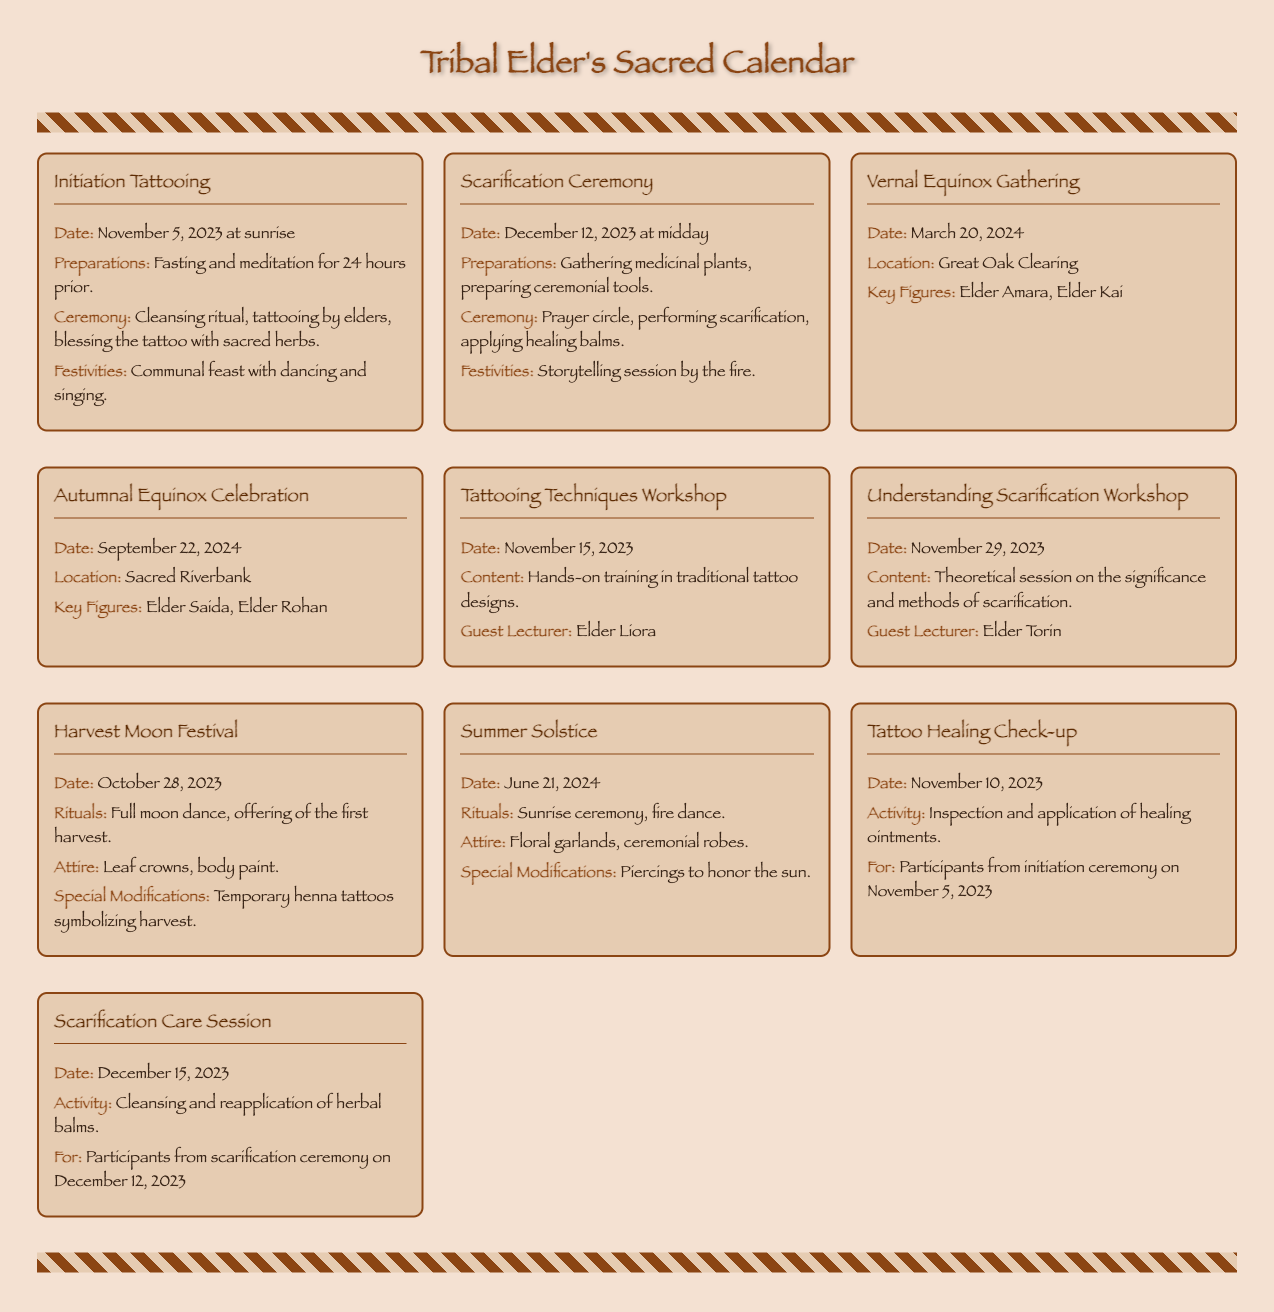What is the date for the Initiation Tattooing? The date for the Initiation Tattooing is explicitly stated in the document as November 5, 2023.
Answer: November 5, 2023 Who is the guest lecturer for the Understanding Scarification Workshop? The document mentions that Elder Torin is the guest lecturer for this workshop.
Answer: Elder Torin What are the special modifications for the Harvest Moon Festival? The document provides specific details about the special modifications being temporary henna tattoos symbolizing harvest.
Answer: Temporary henna tattoos symbolizing harvest When is the Tattoo Healing Check-up scheduled? The date for the Tattoo Healing Check-up is stated in the document as November 10, 2023.
Answer: November 10, 2023 What location is specified for the Vernal Equinox Gathering? The document clearly indicates that the location for this gathering is Great Oak Clearing.
Answer: Great Oak Clearing What type of ceremony occurs at midday on December 12, 2023? The document lists the ceremony occurring at this time as the Scarification Ceremony.
Answer: Scarification Ceremony How many workshops are listed in the calendar? By reviewing the document, it shows that there are two workshops mentioned: Tattooing Techniques Workshop and Understanding Scarification Workshop.
Answer: Two What is the main activity for the Scarification Care Session? The document specifies that the main activity for this session is cleansing and reapplication of herbal balms.
Answer: Cleansing and reapplication of herbal balms What attire is mentioned for the Summer Solstice? The document states that the attire for the Summer Solstice includes floral garlands and ceremonial robes.
Answer: Floral garlands, ceremonial robes 